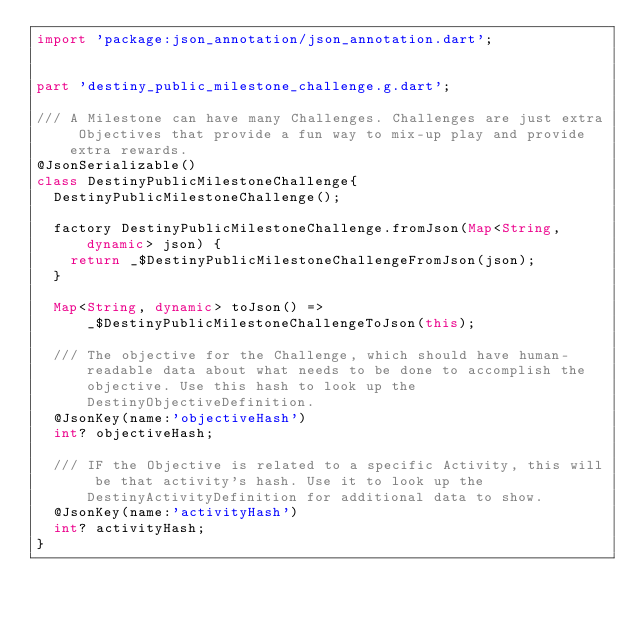Convert code to text. <code><loc_0><loc_0><loc_500><loc_500><_Dart_>import 'package:json_annotation/json_annotation.dart';


part 'destiny_public_milestone_challenge.g.dart';

/// A Milestone can have many Challenges. Challenges are just extra Objectives that provide a fun way to mix-up play and provide extra rewards.
@JsonSerializable()
class DestinyPublicMilestoneChallenge{	
	DestinyPublicMilestoneChallenge();

	factory DestinyPublicMilestoneChallenge.fromJson(Map<String, dynamic> json) {
		return _$DestinyPublicMilestoneChallengeFromJson(json);
	}
	
	Map<String, dynamic> toJson() => _$DestinyPublicMilestoneChallengeToJson(this);
	
	/// The objective for the Challenge, which should have human-readable data about what needs to be done to accomplish the objective. Use this hash to look up the DestinyObjectiveDefinition.
	@JsonKey(name:'objectiveHash')
	int? objectiveHash;
	
	/// IF the Objective is related to a specific Activity, this will be that activity's hash. Use it to look up the DestinyActivityDefinition for additional data to show.
	@JsonKey(name:'activityHash')
	int? activityHash;
}</code> 